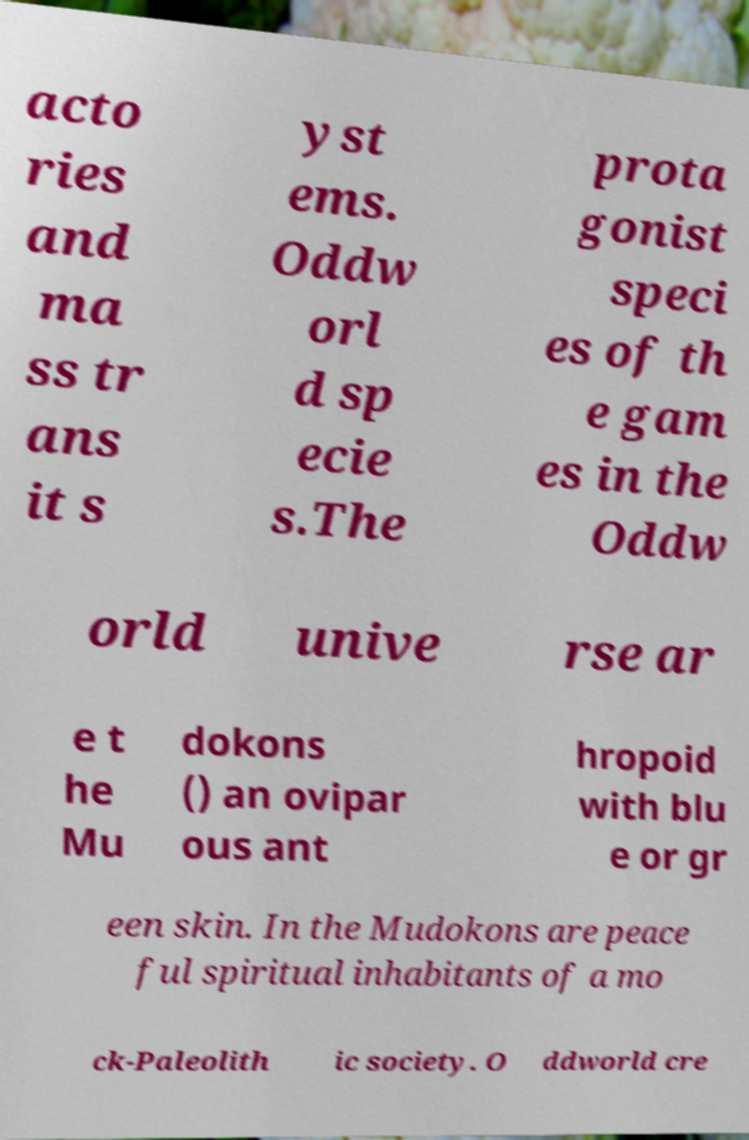I need the written content from this picture converted into text. Can you do that? acto ries and ma ss tr ans it s yst ems. Oddw orl d sp ecie s.The prota gonist speci es of th e gam es in the Oddw orld unive rse ar e t he Mu dokons () an ovipar ous ant hropoid with blu e or gr een skin. In the Mudokons are peace ful spiritual inhabitants of a mo ck-Paleolith ic society. O ddworld cre 